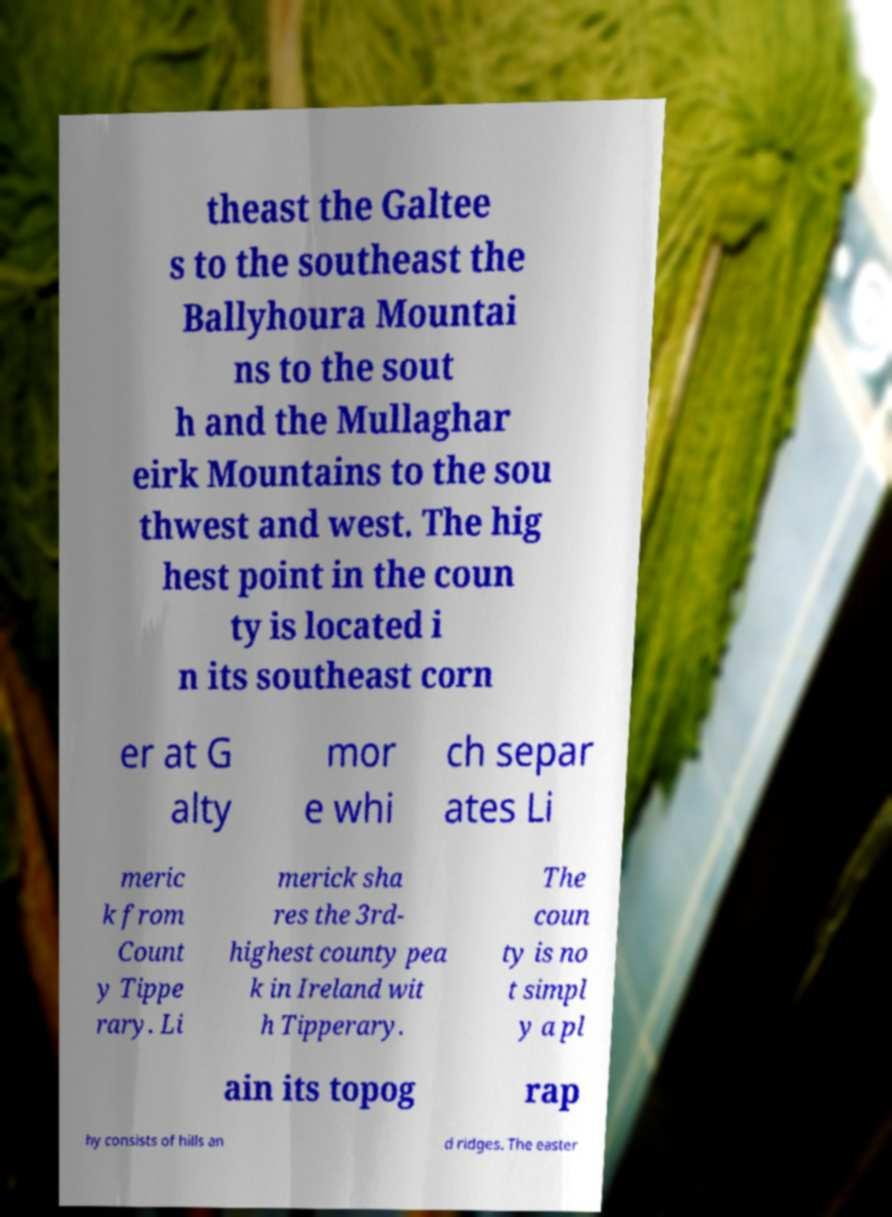Can you read and provide the text displayed in the image?This photo seems to have some interesting text. Can you extract and type it out for me? theast the Galtee s to the southeast the Ballyhoura Mountai ns to the sout h and the Mullaghar eirk Mountains to the sou thwest and west. The hig hest point in the coun ty is located i n its southeast corn er at G alty mor e whi ch separ ates Li meric k from Count y Tippe rary. Li merick sha res the 3rd- highest county pea k in Ireland wit h Tipperary. The coun ty is no t simpl y a pl ain its topog rap hy consists of hills an d ridges. The easter 